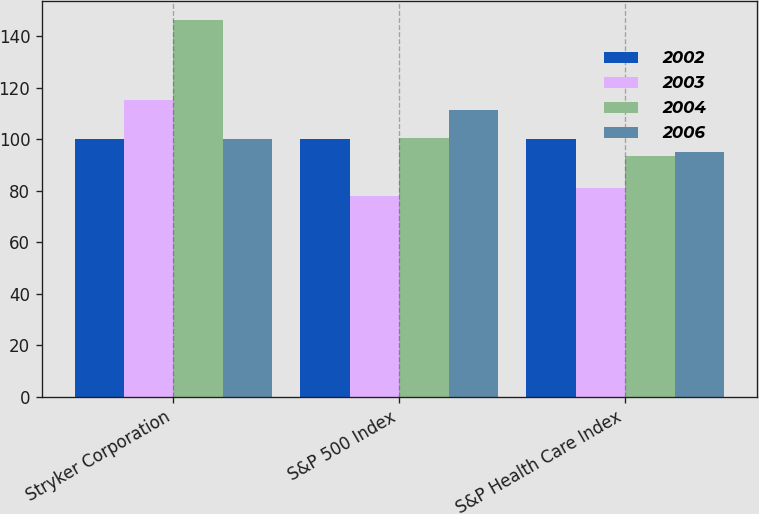Convert chart. <chart><loc_0><loc_0><loc_500><loc_500><stacked_bar_chart><ecel><fcel>Stryker Corporation<fcel>S&P 500 Index<fcel>S&P Health Care Index<nl><fcel>2002<fcel>100<fcel>100<fcel>100<nl><fcel>2003<fcel>115.2<fcel>77.9<fcel>81.18<nl><fcel>2004<fcel>146.14<fcel>100.25<fcel>93.4<nl><fcel>2006<fcel>100<fcel>111.15<fcel>94.96<nl></chart> 